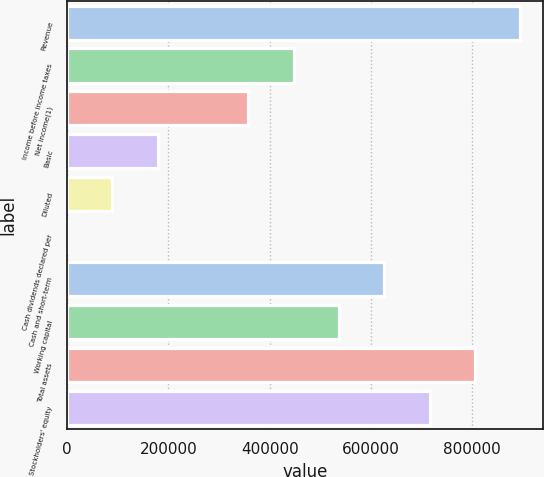Convert chart to OTSL. <chart><loc_0><loc_0><loc_500><loc_500><bar_chart><fcel>Revenue<fcel>Income before income taxes<fcel>Net income(1)<fcel>Basic<fcel>Diluted<fcel>Cash dividends declared per<fcel>Cash and short-term<fcel>Working capital<fcel>Total assets<fcel>Stockholders' equity<nl><fcel>894791<fcel>447396<fcel>357916<fcel>178958<fcel>89479.2<fcel>0.1<fcel>626354<fcel>536875<fcel>805312<fcel>715833<nl></chart> 